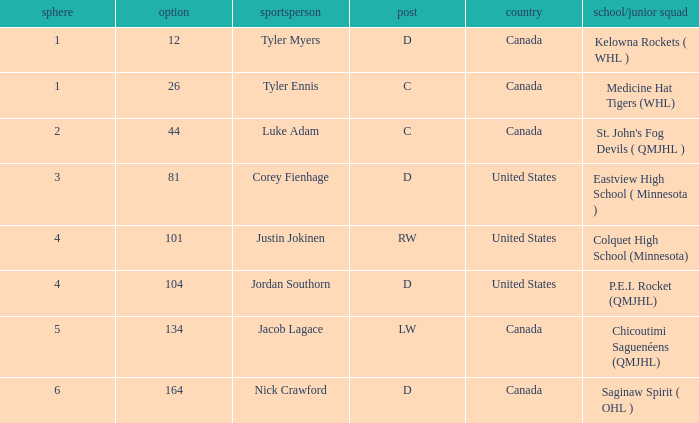What is the nationality of player corey fienhage, who has a pick less than 104? United States. 